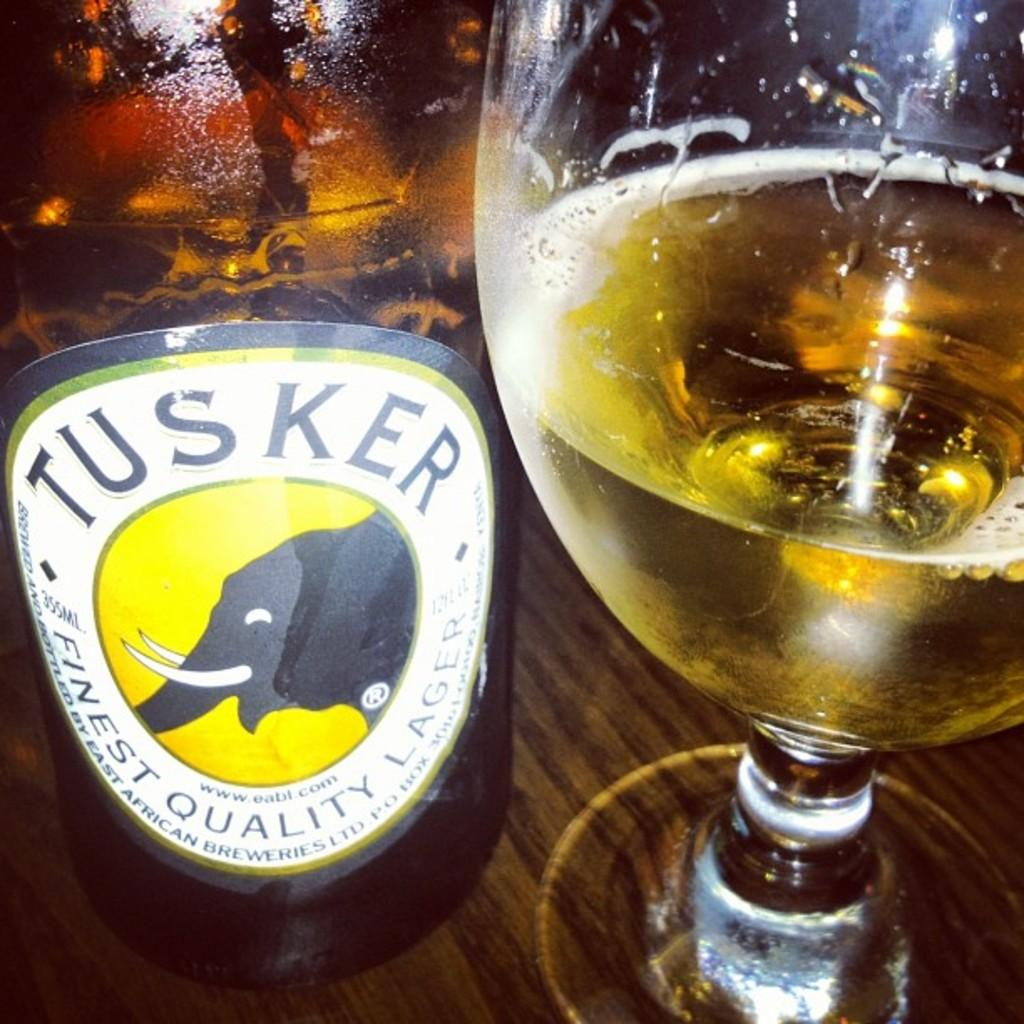<image>
Give a short and clear explanation of the subsequent image. a tusker label that is on a beer 